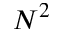<formula> <loc_0><loc_0><loc_500><loc_500>N ^ { 2 }</formula> 